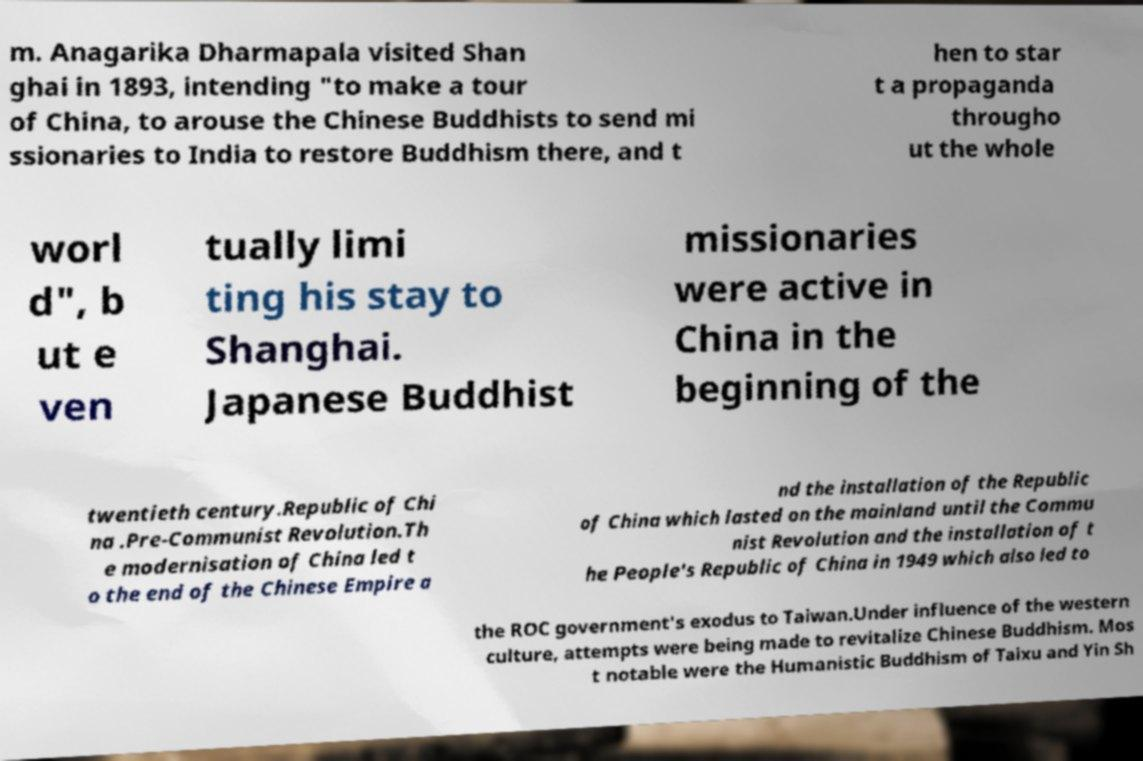What messages or text are displayed in this image? I need them in a readable, typed format. m. Anagarika Dharmapala visited Shan ghai in 1893, intending "to make a tour of China, to arouse the Chinese Buddhists to send mi ssionaries to India to restore Buddhism there, and t hen to star t a propaganda througho ut the whole worl d", b ut e ven tually limi ting his stay to Shanghai. Japanese Buddhist missionaries were active in China in the beginning of the twentieth century.Republic of Chi na .Pre-Communist Revolution.Th e modernisation of China led t o the end of the Chinese Empire a nd the installation of the Republic of China which lasted on the mainland until the Commu nist Revolution and the installation of t he People's Republic of China in 1949 which also led to the ROC government's exodus to Taiwan.Under influence of the western culture, attempts were being made to revitalize Chinese Buddhism. Mos t notable were the Humanistic Buddhism of Taixu and Yin Sh 